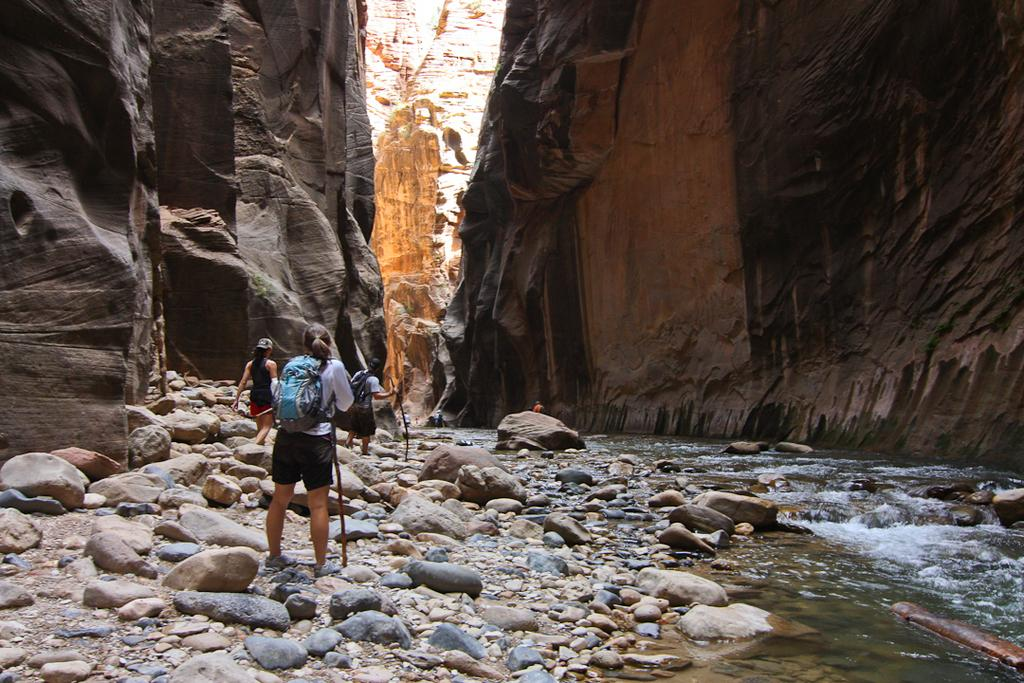Who or what can be seen in the image? There are people in the image. What type of natural elements are present in the image? There are stones and water visible in the image. What surrounds the scene in the image? There are rocks on either side of the image. What type of wall can be seen in the image? There is no wall present in the image. What selection of items can be seen in the image? The image does not depict a selection of items; it shows people, stones, water, and rocks. 